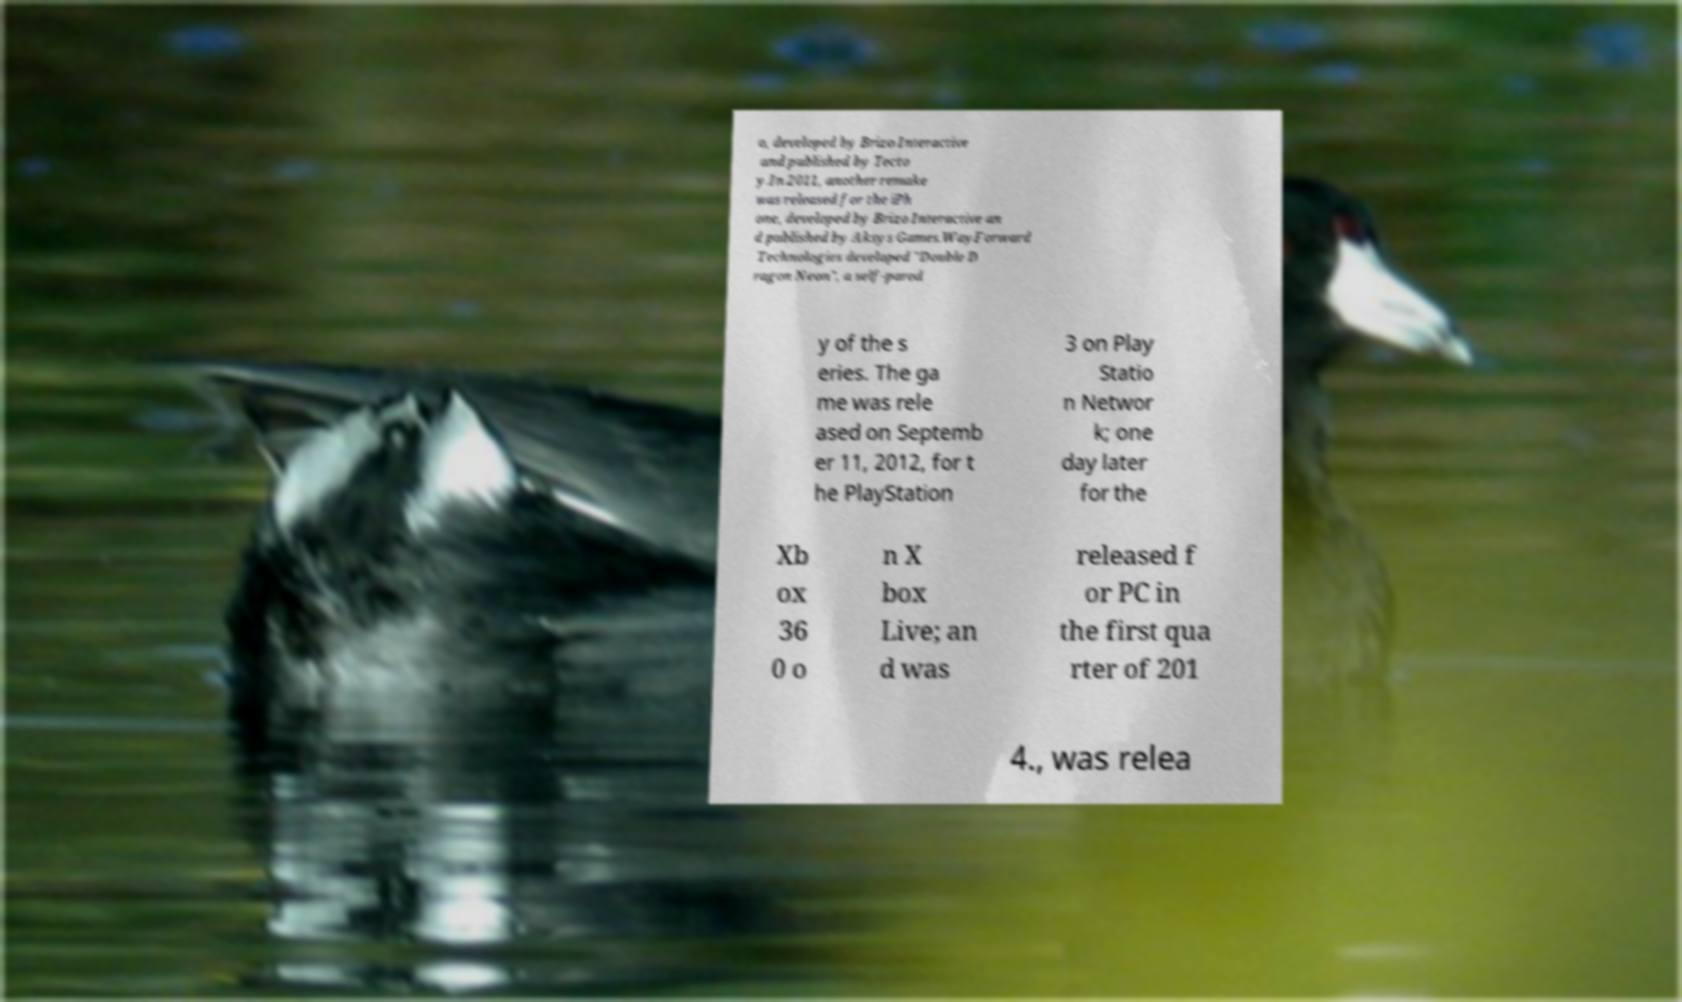Can you read and provide the text displayed in the image?This photo seems to have some interesting text. Can you extract and type it out for me? o, developed by Brizo Interactive and published by Tecto y.In 2011, another remake was released for the iPh one, developed by Brizo Interactive an d published by Aksys Games.WayForward Technologies developed "Double D ragon Neon", a self-parod y of the s eries. The ga me was rele ased on Septemb er 11, 2012, for t he PlayStation 3 on Play Statio n Networ k; one day later for the Xb ox 36 0 o n X box Live; an d was released f or PC in the first qua rter of 201 4., was relea 